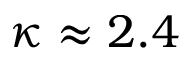<formula> <loc_0><loc_0><loc_500><loc_500>\kappa \approx 2 . 4</formula> 